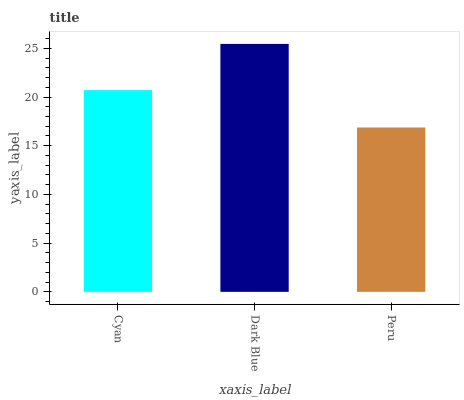Is Peru the minimum?
Answer yes or no. Yes. Is Dark Blue the maximum?
Answer yes or no. Yes. Is Dark Blue the minimum?
Answer yes or no. No. Is Peru the maximum?
Answer yes or no. No. Is Dark Blue greater than Peru?
Answer yes or no. Yes. Is Peru less than Dark Blue?
Answer yes or no. Yes. Is Peru greater than Dark Blue?
Answer yes or no. No. Is Dark Blue less than Peru?
Answer yes or no. No. Is Cyan the high median?
Answer yes or no. Yes. Is Cyan the low median?
Answer yes or no. Yes. Is Dark Blue the high median?
Answer yes or no. No. Is Dark Blue the low median?
Answer yes or no. No. 